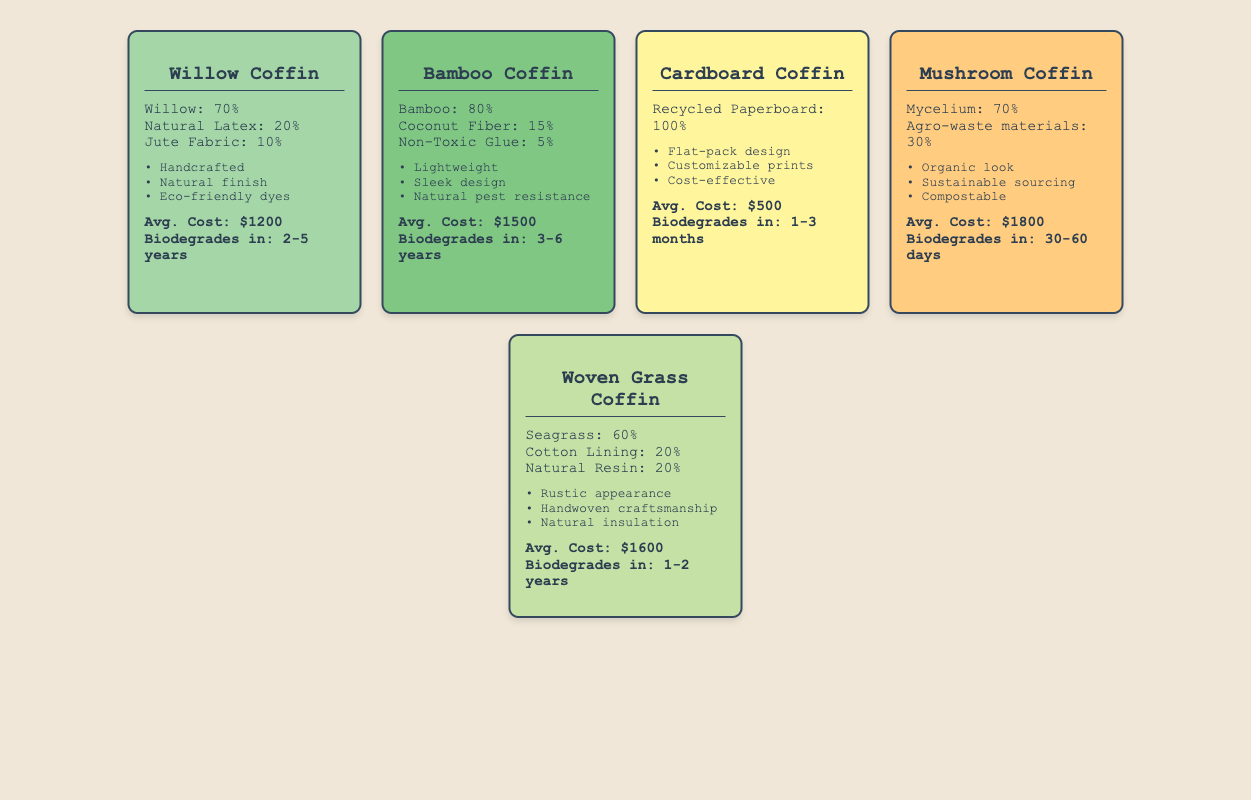What is the average cost of the biodegradable coffins listed? The average cost can be calculated by adding the individual costs of each coffin: $1200 (Willow) + $1500 (Bamboo) + $500 (Cardboard) + $1800 (Mushroom) + $1600 (Woven Grass) = $4600. There are 5 coffins, so the average cost is $4600 / 5 = $920.
Answer: 920 Which coffin has the shortest biodegradation time? The biodegradation times for the coffins are: Willow: 2-5 years, Bamboo: 3-6 years, Cardboard: 1-3 months, Mushroom: 30-60 days, and Woven Grass: 1-2 years. The shortest time is 30-60 days for the Mushroom Coffin.
Answer: Mushroom Coffin Is the Bamboo Coffin more expensive than the Woven Grass Coffin? The average cost of the Bamboo Coffin is $1500, while the Woven Grass Coffin costs $1600. Since $1500 is less than $1600, the statement is false.
Answer: No What percentage of the Wood Coffin is Natural Latex? From the data, we see that the Willow Coffin has a composition of 70% Willow, 20% Natural Latex, and 10% Jute Fabric. The percentage of Natural Latex in the Willow Coffin is directly given as 20%.
Answer: 20% Which coffin has the longest biodegradation time? The longest biodegradation time is found by comparing: Willow: 2-5 years, Bamboo: 3-6 years, Cardboard: 1-3 months, Mushroom: 30-60 days, and Woven Grass: 1-2 years. The Bamboo Coffin has the longest range: 3-6 years.
Answer: Bamboo Coffin Is it true that all coffins are handcrafted? The design features listed show that only the Willow Coffin is marked as handcrafted. Thus, the statement that all coffins are handcrafted is false.
Answer: No What is the combined percentage of materials in the Cardboard Coffin? The Cardboard Coffin is made entirely from recycled paperboard, which is 100%. Since there are no other materials listed, the combined percentage is simply 100%.
Answer: 100% Which coffin includes organic material and is compostable? The Mushroom Coffin is noted for its organic look and sustainable sourcing, as well as its compostable feature, making it clearly identifiable as the coffin that meets these criteria.
Answer: Mushroom Coffin 